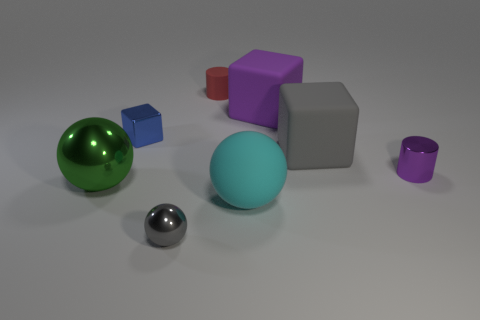Is the color of the large thing that is behind the large gray rubber thing the same as the cylinder that is in front of the small cube?
Provide a short and direct response. Yes. There is a tiny thing that is both left of the purple matte cube and on the right side of the tiny gray sphere; what is its material?
Keep it short and to the point. Rubber. What color is the large matte ball?
Provide a short and direct response. Cyan. How many other objects are there of the same shape as the blue shiny thing?
Give a very brief answer. 2. Are there an equal number of small metal spheres that are to the right of the tiny red thing and tiny metallic spheres left of the gray shiny sphere?
Provide a succinct answer. Yes. What is the big green sphere made of?
Your answer should be compact. Metal. There is a big cube behind the large gray cube; what is its material?
Your response must be concise. Rubber. Are there more balls left of the small rubber cylinder than large green metal cylinders?
Offer a terse response. Yes. There is a small cylinder left of the tiny thing right of the red cylinder; is there a purple metallic cylinder that is left of it?
Give a very brief answer. No. There is a tiny blue shiny thing; are there any small metal things to the right of it?
Provide a short and direct response. Yes. 